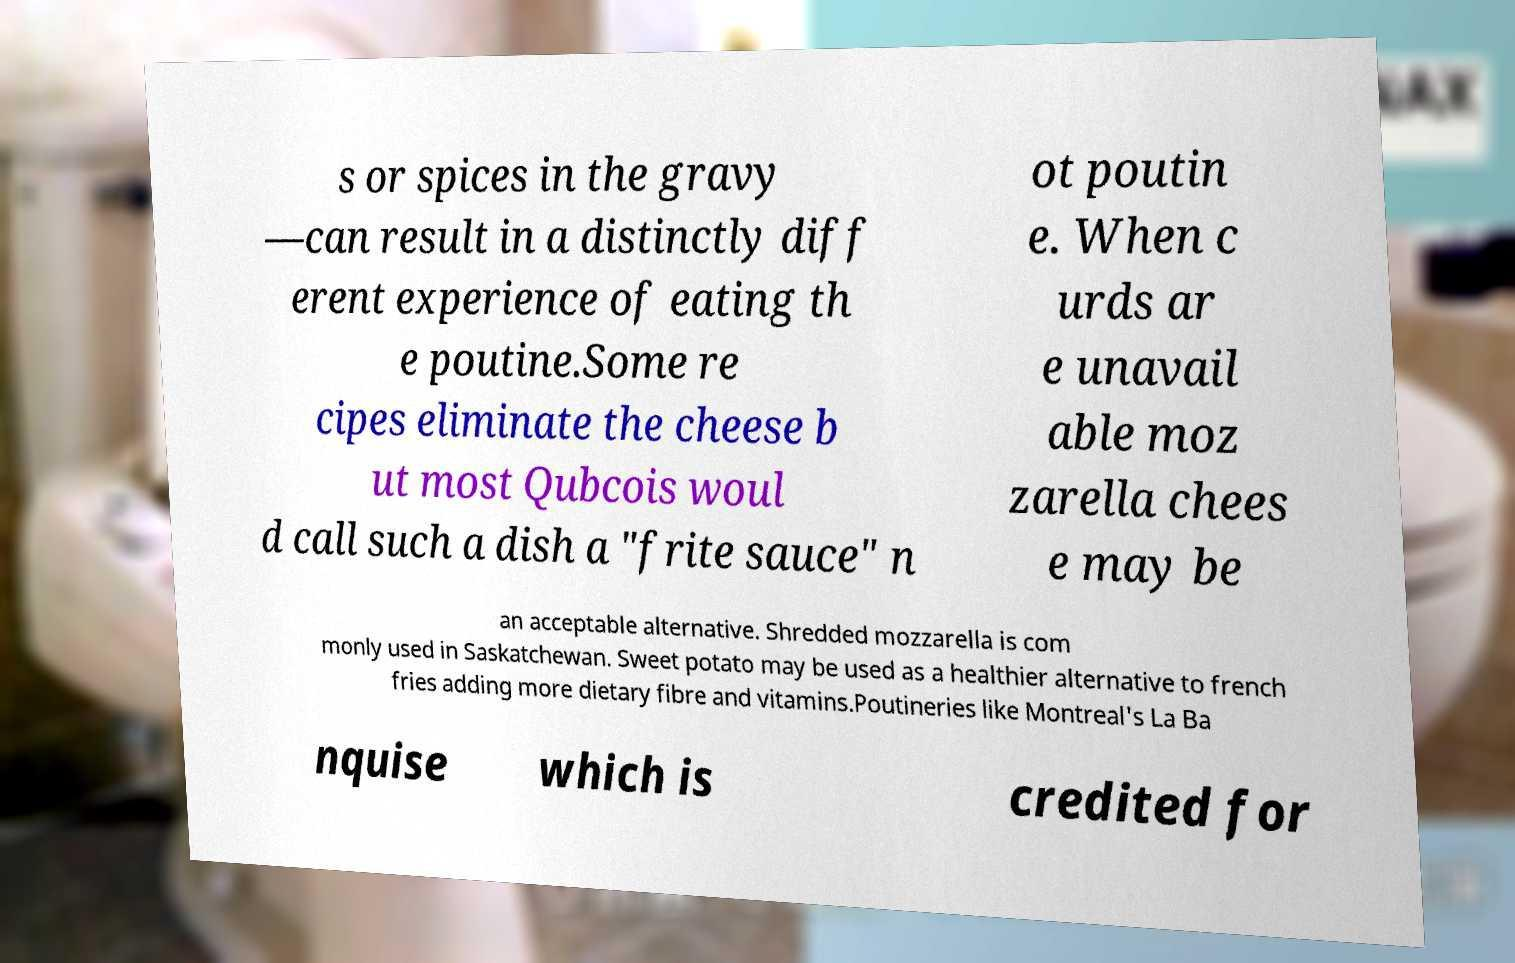There's text embedded in this image that I need extracted. Can you transcribe it verbatim? s or spices in the gravy —can result in a distinctly diff erent experience of eating th e poutine.Some re cipes eliminate the cheese b ut most Qubcois woul d call such a dish a "frite sauce" n ot poutin e. When c urds ar e unavail able moz zarella chees e may be an acceptable alternative. Shredded mozzarella is com monly used in Saskatchewan. Sweet potato may be used as a healthier alternative to french fries adding more dietary fibre and vitamins.Poutineries like Montreal's La Ba nquise which is credited for 